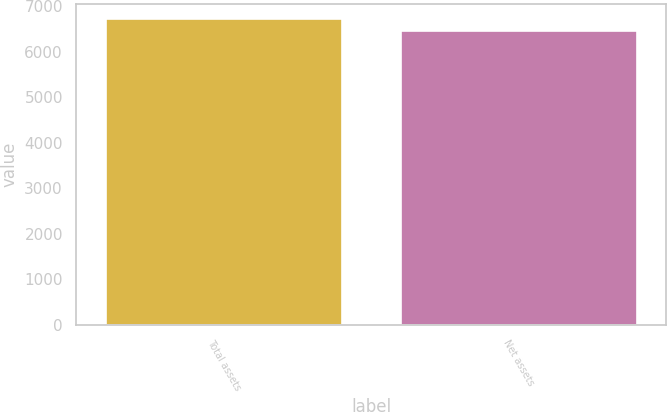Convert chart. <chart><loc_0><loc_0><loc_500><loc_500><bar_chart><fcel>Total assets<fcel>Net assets<nl><fcel>6716<fcel>6464<nl></chart> 